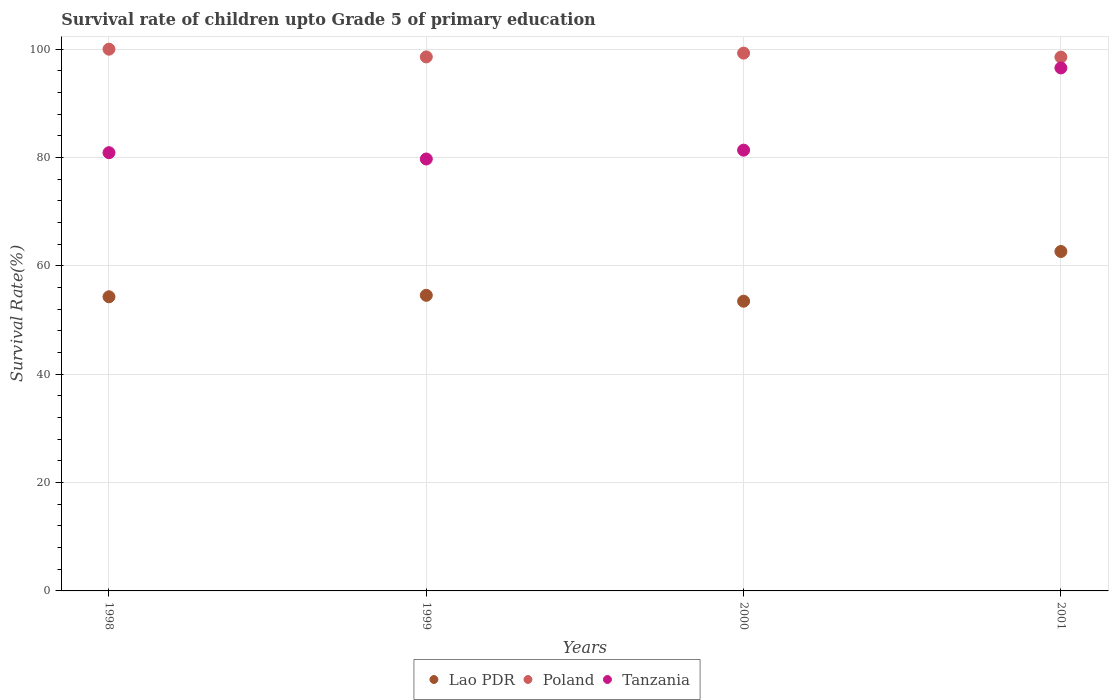How many different coloured dotlines are there?
Offer a very short reply. 3. What is the survival rate of children in Lao PDR in 2001?
Your answer should be compact. 62.66. Across all years, what is the minimum survival rate of children in Tanzania?
Make the answer very short. 79.73. What is the total survival rate of children in Poland in the graph?
Offer a terse response. 396.38. What is the difference between the survival rate of children in Tanzania in 1998 and that in 2001?
Provide a short and direct response. -15.65. What is the difference between the survival rate of children in Poland in 1999 and the survival rate of children in Tanzania in 2000?
Offer a terse response. 17.21. What is the average survival rate of children in Poland per year?
Your response must be concise. 99.1. In the year 1999, what is the difference between the survival rate of children in Tanzania and survival rate of children in Poland?
Provide a succinct answer. -18.84. In how many years, is the survival rate of children in Poland greater than 24 %?
Your answer should be compact. 4. What is the ratio of the survival rate of children in Poland in 1999 to that in 2001?
Offer a terse response. 1. Is the survival rate of children in Poland in 1998 less than that in 2000?
Offer a very short reply. No. Is the difference between the survival rate of children in Tanzania in 1998 and 2001 greater than the difference between the survival rate of children in Poland in 1998 and 2001?
Your answer should be compact. No. What is the difference between the highest and the second highest survival rate of children in Poland?
Offer a very short reply. 0.73. What is the difference between the highest and the lowest survival rate of children in Tanzania?
Give a very brief answer. 16.81. In how many years, is the survival rate of children in Tanzania greater than the average survival rate of children in Tanzania taken over all years?
Ensure brevity in your answer.  1. Is the sum of the survival rate of children in Lao PDR in 1999 and 2000 greater than the maximum survival rate of children in Tanzania across all years?
Make the answer very short. Yes. Is it the case that in every year, the sum of the survival rate of children in Lao PDR and survival rate of children in Poland  is greater than the survival rate of children in Tanzania?
Make the answer very short. Yes. Is the survival rate of children in Lao PDR strictly less than the survival rate of children in Tanzania over the years?
Provide a succinct answer. Yes. How many dotlines are there?
Offer a terse response. 3. What is the difference between two consecutive major ticks on the Y-axis?
Provide a short and direct response. 20. Does the graph contain any zero values?
Provide a short and direct response. No. How are the legend labels stacked?
Ensure brevity in your answer.  Horizontal. What is the title of the graph?
Make the answer very short. Survival rate of children upto Grade 5 of primary education. What is the label or title of the Y-axis?
Your answer should be very brief. Survival Rate(%). What is the Survival Rate(%) in Lao PDR in 1998?
Make the answer very short. 54.29. What is the Survival Rate(%) of Tanzania in 1998?
Give a very brief answer. 80.89. What is the Survival Rate(%) of Lao PDR in 1999?
Offer a terse response. 54.57. What is the Survival Rate(%) in Poland in 1999?
Make the answer very short. 98.57. What is the Survival Rate(%) of Tanzania in 1999?
Keep it short and to the point. 79.73. What is the Survival Rate(%) of Lao PDR in 2000?
Your answer should be compact. 53.48. What is the Survival Rate(%) of Poland in 2000?
Make the answer very short. 99.27. What is the Survival Rate(%) of Tanzania in 2000?
Offer a terse response. 81.36. What is the Survival Rate(%) of Lao PDR in 2001?
Ensure brevity in your answer.  62.66. What is the Survival Rate(%) in Poland in 2001?
Your response must be concise. 98.54. What is the Survival Rate(%) of Tanzania in 2001?
Your response must be concise. 96.54. Across all years, what is the maximum Survival Rate(%) in Lao PDR?
Keep it short and to the point. 62.66. Across all years, what is the maximum Survival Rate(%) in Poland?
Your answer should be very brief. 100. Across all years, what is the maximum Survival Rate(%) of Tanzania?
Give a very brief answer. 96.54. Across all years, what is the minimum Survival Rate(%) in Lao PDR?
Give a very brief answer. 53.48. Across all years, what is the minimum Survival Rate(%) in Poland?
Ensure brevity in your answer.  98.54. Across all years, what is the minimum Survival Rate(%) in Tanzania?
Provide a succinct answer. 79.73. What is the total Survival Rate(%) of Lao PDR in the graph?
Give a very brief answer. 224.99. What is the total Survival Rate(%) of Poland in the graph?
Your response must be concise. 396.38. What is the total Survival Rate(%) of Tanzania in the graph?
Offer a terse response. 338.53. What is the difference between the Survival Rate(%) of Lao PDR in 1998 and that in 1999?
Your answer should be very brief. -0.27. What is the difference between the Survival Rate(%) of Poland in 1998 and that in 1999?
Offer a terse response. 1.43. What is the difference between the Survival Rate(%) in Lao PDR in 1998 and that in 2000?
Your response must be concise. 0.82. What is the difference between the Survival Rate(%) of Poland in 1998 and that in 2000?
Give a very brief answer. 0.73. What is the difference between the Survival Rate(%) of Tanzania in 1998 and that in 2000?
Your response must be concise. -0.47. What is the difference between the Survival Rate(%) of Lao PDR in 1998 and that in 2001?
Your answer should be compact. -8.36. What is the difference between the Survival Rate(%) in Poland in 1998 and that in 2001?
Offer a very short reply. 1.46. What is the difference between the Survival Rate(%) in Tanzania in 1998 and that in 2001?
Make the answer very short. -15.65. What is the difference between the Survival Rate(%) of Lao PDR in 1999 and that in 2000?
Your response must be concise. 1.09. What is the difference between the Survival Rate(%) in Poland in 1999 and that in 2000?
Make the answer very short. -0.7. What is the difference between the Survival Rate(%) in Tanzania in 1999 and that in 2000?
Your answer should be very brief. -1.63. What is the difference between the Survival Rate(%) of Lao PDR in 1999 and that in 2001?
Your response must be concise. -8.09. What is the difference between the Survival Rate(%) in Poland in 1999 and that in 2001?
Ensure brevity in your answer.  0.04. What is the difference between the Survival Rate(%) in Tanzania in 1999 and that in 2001?
Provide a succinct answer. -16.81. What is the difference between the Survival Rate(%) of Lao PDR in 2000 and that in 2001?
Offer a terse response. -9.18. What is the difference between the Survival Rate(%) of Poland in 2000 and that in 2001?
Make the answer very short. 0.74. What is the difference between the Survival Rate(%) in Tanzania in 2000 and that in 2001?
Give a very brief answer. -15.18. What is the difference between the Survival Rate(%) in Lao PDR in 1998 and the Survival Rate(%) in Poland in 1999?
Keep it short and to the point. -44.28. What is the difference between the Survival Rate(%) of Lao PDR in 1998 and the Survival Rate(%) of Tanzania in 1999?
Offer a terse response. -25.43. What is the difference between the Survival Rate(%) of Poland in 1998 and the Survival Rate(%) of Tanzania in 1999?
Offer a terse response. 20.27. What is the difference between the Survival Rate(%) in Lao PDR in 1998 and the Survival Rate(%) in Poland in 2000?
Your response must be concise. -44.98. What is the difference between the Survival Rate(%) in Lao PDR in 1998 and the Survival Rate(%) in Tanzania in 2000?
Your answer should be compact. -27.07. What is the difference between the Survival Rate(%) of Poland in 1998 and the Survival Rate(%) of Tanzania in 2000?
Your answer should be very brief. 18.64. What is the difference between the Survival Rate(%) in Lao PDR in 1998 and the Survival Rate(%) in Poland in 2001?
Your answer should be compact. -44.24. What is the difference between the Survival Rate(%) in Lao PDR in 1998 and the Survival Rate(%) in Tanzania in 2001?
Provide a short and direct response. -42.25. What is the difference between the Survival Rate(%) in Poland in 1998 and the Survival Rate(%) in Tanzania in 2001?
Offer a very short reply. 3.46. What is the difference between the Survival Rate(%) in Lao PDR in 1999 and the Survival Rate(%) in Poland in 2000?
Give a very brief answer. -44.71. What is the difference between the Survival Rate(%) in Lao PDR in 1999 and the Survival Rate(%) in Tanzania in 2000?
Offer a very short reply. -26.79. What is the difference between the Survival Rate(%) in Poland in 1999 and the Survival Rate(%) in Tanzania in 2000?
Offer a very short reply. 17.21. What is the difference between the Survival Rate(%) in Lao PDR in 1999 and the Survival Rate(%) in Poland in 2001?
Give a very brief answer. -43.97. What is the difference between the Survival Rate(%) in Lao PDR in 1999 and the Survival Rate(%) in Tanzania in 2001?
Make the answer very short. -41.98. What is the difference between the Survival Rate(%) in Poland in 1999 and the Survival Rate(%) in Tanzania in 2001?
Provide a short and direct response. 2.03. What is the difference between the Survival Rate(%) of Lao PDR in 2000 and the Survival Rate(%) of Poland in 2001?
Make the answer very short. -45.06. What is the difference between the Survival Rate(%) in Lao PDR in 2000 and the Survival Rate(%) in Tanzania in 2001?
Provide a short and direct response. -43.06. What is the difference between the Survival Rate(%) in Poland in 2000 and the Survival Rate(%) in Tanzania in 2001?
Your answer should be very brief. 2.73. What is the average Survival Rate(%) of Lao PDR per year?
Provide a short and direct response. 56.25. What is the average Survival Rate(%) of Poland per year?
Ensure brevity in your answer.  99.1. What is the average Survival Rate(%) of Tanzania per year?
Ensure brevity in your answer.  84.63. In the year 1998, what is the difference between the Survival Rate(%) in Lao PDR and Survival Rate(%) in Poland?
Offer a very short reply. -45.71. In the year 1998, what is the difference between the Survival Rate(%) in Lao PDR and Survival Rate(%) in Tanzania?
Give a very brief answer. -26.6. In the year 1998, what is the difference between the Survival Rate(%) of Poland and Survival Rate(%) of Tanzania?
Make the answer very short. 19.11. In the year 1999, what is the difference between the Survival Rate(%) of Lao PDR and Survival Rate(%) of Poland?
Make the answer very short. -44.01. In the year 1999, what is the difference between the Survival Rate(%) of Lao PDR and Survival Rate(%) of Tanzania?
Offer a terse response. -25.16. In the year 1999, what is the difference between the Survival Rate(%) in Poland and Survival Rate(%) in Tanzania?
Give a very brief answer. 18.84. In the year 2000, what is the difference between the Survival Rate(%) of Lao PDR and Survival Rate(%) of Poland?
Your answer should be very brief. -45.79. In the year 2000, what is the difference between the Survival Rate(%) in Lao PDR and Survival Rate(%) in Tanzania?
Offer a very short reply. -27.88. In the year 2000, what is the difference between the Survival Rate(%) of Poland and Survival Rate(%) of Tanzania?
Give a very brief answer. 17.91. In the year 2001, what is the difference between the Survival Rate(%) of Lao PDR and Survival Rate(%) of Poland?
Provide a short and direct response. -35.88. In the year 2001, what is the difference between the Survival Rate(%) of Lao PDR and Survival Rate(%) of Tanzania?
Provide a succinct answer. -33.89. In the year 2001, what is the difference between the Survival Rate(%) of Poland and Survival Rate(%) of Tanzania?
Make the answer very short. 1.99. What is the ratio of the Survival Rate(%) of Poland in 1998 to that in 1999?
Offer a terse response. 1.01. What is the ratio of the Survival Rate(%) in Tanzania in 1998 to that in 1999?
Your answer should be very brief. 1.01. What is the ratio of the Survival Rate(%) of Lao PDR in 1998 to that in 2000?
Your answer should be compact. 1.02. What is the ratio of the Survival Rate(%) in Poland in 1998 to that in 2000?
Offer a very short reply. 1.01. What is the ratio of the Survival Rate(%) in Tanzania in 1998 to that in 2000?
Make the answer very short. 0.99. What is the ratio of the Survival Rate(%) of Lao PDR in 1998 to that in 2001?
Offer a very short reply. 0.87. What is the ratio of the Survival Rate(%) in Poland in 1998 to that in 2001?
Your answer should be very brief. 1.01. What is the ratio of the Survival Rate(%) in Tanzania in 1998 to that in 2001?
Ensure brevity in your answer.  0.84. What is the ratio of the Survival Rate(%) in Lao PDR in 1999 to that in 2000?
Give a very brief answer. 1.02. What is the ratio of the Survival Rate(%) of Tanzania in 1999 to that in 2000?
Offer a terse response. 0.98. What is the ratio of the Survival Rate(%) in Lao PDR in 1999 to that in 2001?
Provide a short and direct response. 0.87. What is the ratio of the Survival Rate(%) in Tanzania in 1999 to that in 2001?
Give a very brief answer. 0.83. What is the ratio of the Survival Rate(%) of Lao PDR in 2000 to that in 2001?
Your response must be concise. 0.85. What is the ratio of the Survival Rate(%) in Poland in 2000 to that in 2001?
Keep it short and to the point. 1.01. What is the ratio of the Survival Rate(%) in Tanzania in 2000 to that in 2001?
Offer a very short reply. 0.84. What is the difference between the highest and the second highest Survival Rate(%) of Lao PDR?
Your answer should be very brief. 8.09. What is the difference between the highest and the second highest Survival Rate(%) in Poland?
Offer a terse response. 0.73. What is the difference between the highest and the second highest Survival Rate(%) in Tanzania?
Offer a terse response. 15.18. What is the difference between the highest and the lowest Survival Rate(%) of Lao PDR?
Offer a terse response. 9.18. What is the difference between the highest and the lowest Survival Rate(%) of Poland?
Give a very brief answer. 1.46. What is the difference between the highest and the lowest Survival Rate(%) of Tanzania?
Your answer should be compact. 16.81. 